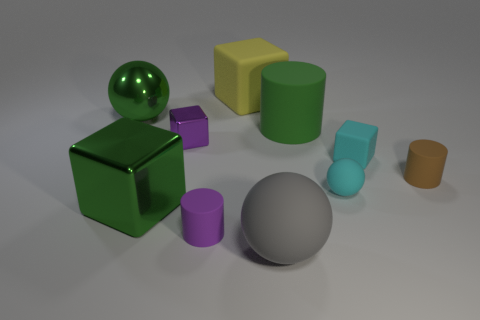Subtract all cylinders. How many objects are left? 7 Subtract 1 green cylinders. How many objects are left? 9 Subtract all large gray rubber balls. Subtract all tiny green cubes. How many objects are left? 9 Add 9 small cyan matte balls. How many small cyan matte balls are left? 10 Add 5 shiny balls. How many shiny balls exist? 6 